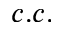Convert formula to latex. <formula><loc_0><loc_0><loc_500><loc_500>c . c .</formula> 